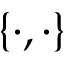Convert formula to latex. <formula><loc_0><loc_0><loc_500><loc_500>\{ \cdot , \cdot \}</formula> 